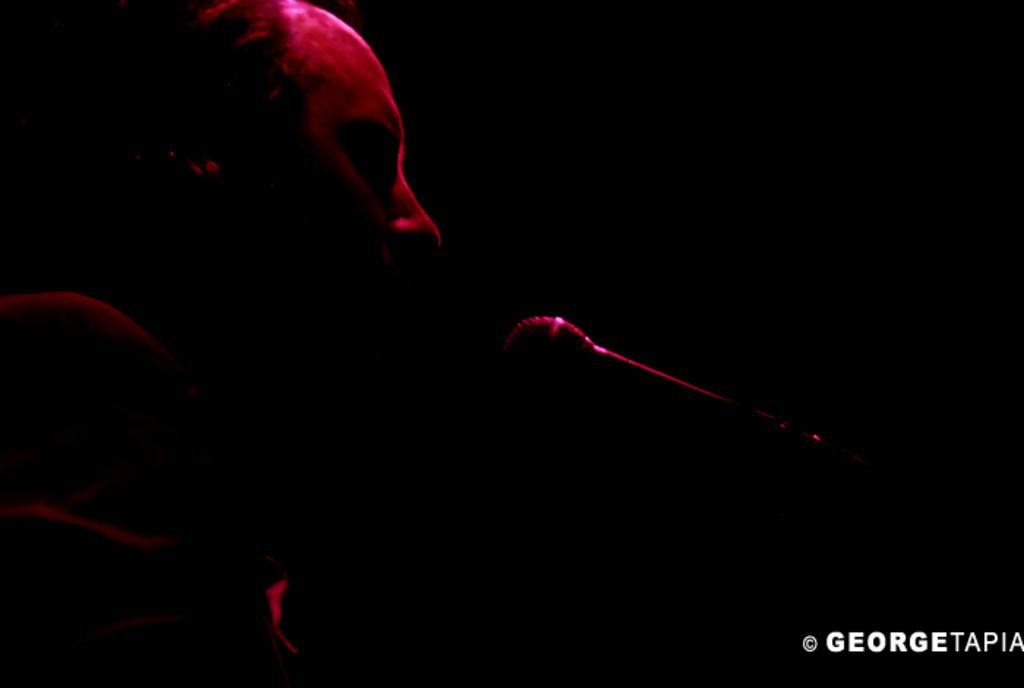Who or what is the main subject in the image? There is a person in the image. What is the person holding in their hand? The person is holding a microphone. Where is the microphone located in relation to the person? The microphone is in the person's hand. Is there any text visible in the image? Yes, there is text in the right bottom corner of the image. What type of weather is depicted in the image? There is no weather depicted in the image; it is a person holding a microphone with text in the corner. How many cats can be seen interacting with the person in the image? There are no cats present in the image. 